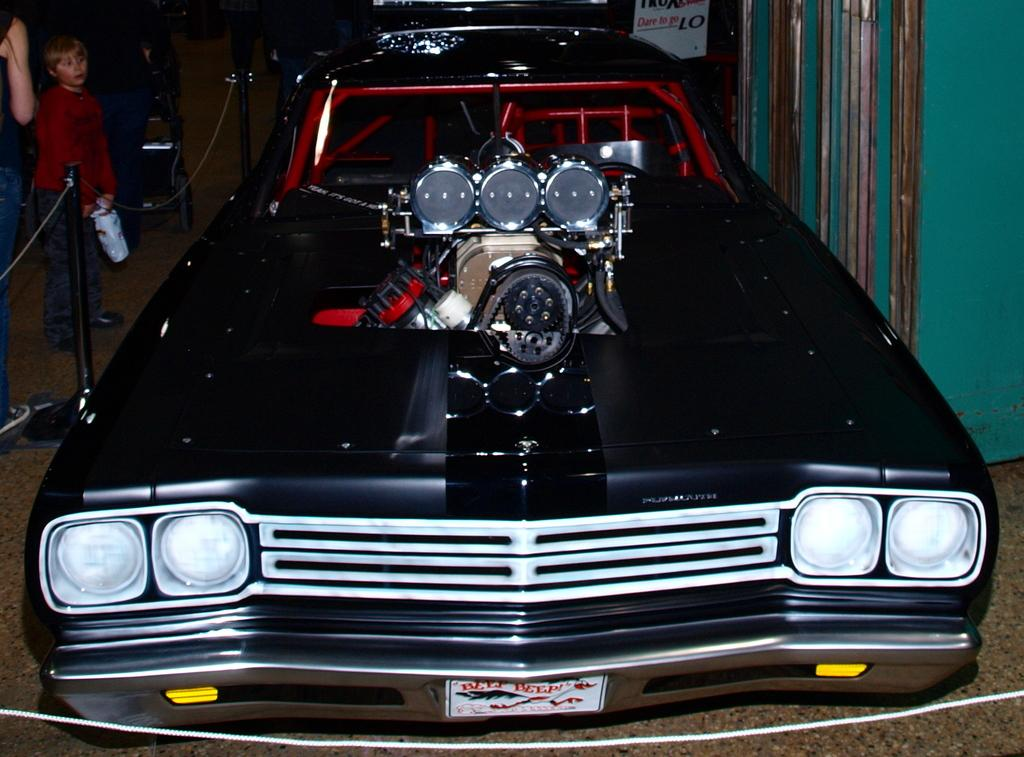What is the main subject of the image? The main subject of the image is a car in the showroom. What type of fence is visible in the image? There is a rod fence in the image. Are there any people present in the image? Yes, people are standing near the rod fence. What type of creature is sitting on the car in the image? There is no creature present on the car in the image. What type of cloth is draped over the car in the image? There is no cloth draped over the car in the image. 